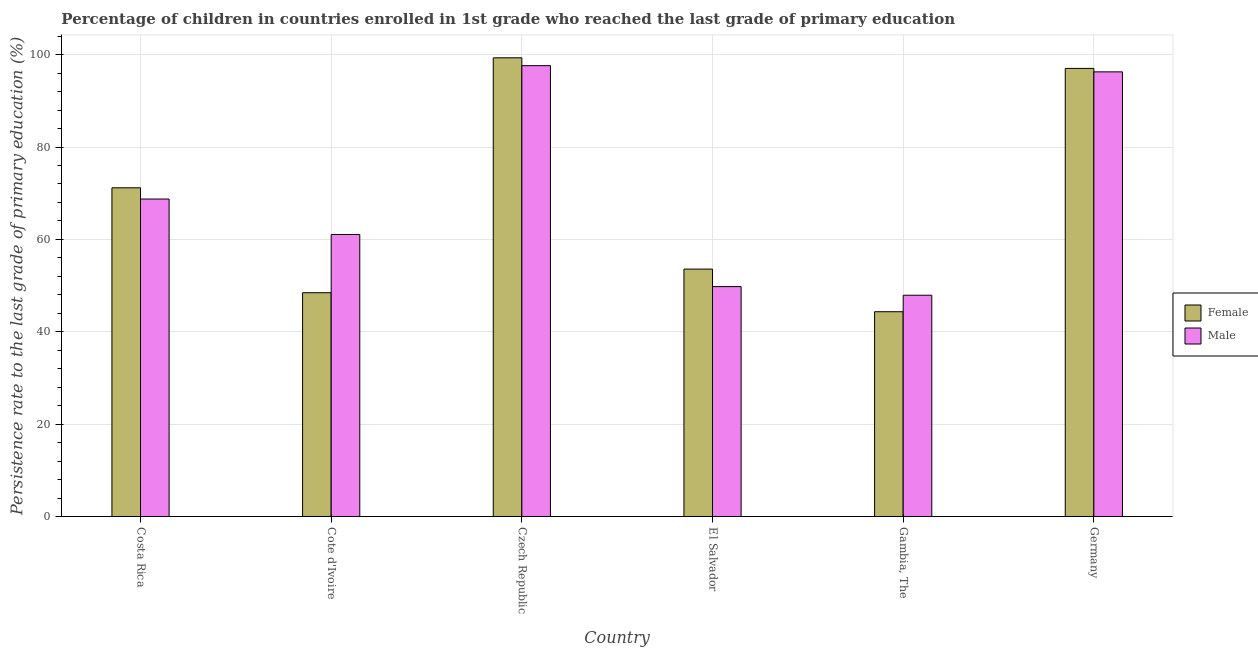How many different coloured bars are there?
Ensure brevity in your answer.  2. How many groups of bars are there?
Your answer should be compact. 6. Are the number of bars on each tick of the X-axis equal?
Your answer should be very brief. Yes. What is the label of the 4th group of bars from the left?
Offer a terse response. El Salvador. In how many cases, is the number of bars for a given country not equal to the number of legend labels?
Keep it short and to the point. 0. What is the persistence rate of female students in Cote d'Ivoire?
Make the answer very short. 48.45. Across all countries, what is the maximum persistence rate of female students?
Keep it short and to the point. 99.33. Across all countries, what is the minimum persistence rate of male students?
Give a very brief answer. 47.91. In which country was the persistence rate of male students maximum?
Your answer should be compact. Czech Republic. In which country was the persistence rate of male students minimum?
Give a very brief answer. Gambia, The. What is the total persistence rate of male students in the graph?
Your answer should be compact. 421.42. What is the difference between the persistence rate of male students in Cote d'Ivoire and that in Gambia, The?
Keep it short and to the point. 13.15. What is the difference between the persistence rate of female students in Gambia, The and the persistence rate of male students in El Salvador?
Your answer should be compact. -5.44. What is the average persistence rate of male students per country?
Provide a short and direct response. 70.24. What is the difference between the persistence rate of female students and persistence rate of male students in Germany?
Provide a succinct answer. 0.75. What is the ratio of the persistence rate of female students in Cote d'Ivoire to that in Czech Republic?
Keep it short and to the point. 0.49. Is the persistence rate of male students in Costa Rica less than that in Germany?
Offer a terse response. Yes. What is the difference between the highest and the second highest persistence rate of male students?
Make the answer very short. 1.34. What is the difference between the highest and the lowest persistence rate of female students?
Your response must be concise. 54.99. In how many countries, is the persistence rate of male students greater than the average persistence rate of male students taken over all countries?
Your response must be concise. 2. Is the sum of the persistence rate of male students in Cote d'Ivoire and Czech Republic greater than the maximum persistence rate of female students across all countries?
Your response must be concise. Yes. Are all the bars in the graph horizontal?
Provide a succinct answer. No. How many countries are there in the graph?
Your answer should be very brief. 6. Are the values on the major ticks of Y-axis written in scientific E-notation?
Offer a terse response. No. How many legend labels are there?
Keep it short and to the point. 2. How are the legend labels stacked?
Your answer should be very brief. Vertical. What is the title of the graph?
Give a very brief answer. Percentage of children in countries enrolled in 1st grade who reached the last grade of primary education. Does "External balance on goods" appear as one of the legend labels in the graph?
Ensure brevity in your answer.  No. What is the label or title of the X-axis?
Offer a very short reply. Country. What is the label or title of the Y-axis?
Make the answer very short. Persistence rate to the last grade of primary education (%). What is the Persistence rate to the last grade of primary education (%) in Female in Costa Rica?
Your response must be concise. 71.18. What is the Persistence rate to the last grade of primary education (%) of Male in Costa Rica?
Ensure brevity in your answer.  68.75. What is the Persistence rate to the last grade of primary education (%) in Female in Cote d'Ivoire?
Provide a short and direct response. 48.45. What is the Persistence rate to the last grade of primary education (%) of Male in Cote d'Ivoire?
Ensure brevity in your answer.  61.06. What is the Persistence rate to the last grade of primary education (%) in Female in Czech Republic?
Provide a short and direct response. 99.33. What is the Persistence rate to the last grade of primary education (%) of Male in Czech Republic?
Provide a short and direct response. 97.63. What is the Persistence rate to the last grade of primary education (%) in Female in El Salvador?
Offer a very short reply. 53.58. What is the Persistence rate to the last grade of primary education (%) in Male in El Salvador?
Your response must be concise. 49.78. What is the Persistence rate to the last grade of primary education (%) in Female in Gambia, The?
Your response must be concise. 44.34. What is the Persistence rate to the last grade of primary education (%) of Male in Gambia, The?
Keep it short and to the point. 47.91. What is the Persistence rate to the last grade of primary education (%) of Female in Germany?
Offer a terse response. 97.03. What is the Persistence rate to the last grade of primary education (%) of Male in Germany?
Offer a very short reply. 96.29. Across all countries, what is the maximum Persistence rate to the last grade of primary education (%) of Female?
Ensure brevity in your answer.  99.33. Across all countries, what is the maximum Persistence rate to the last grade of primary education (%) of Male?
Make the answer very short. 97.63. Across all countries, what is the minimum Persistence rate to the last grade of primary education (%) of Female?
Offer a terse response. 44.34. Across all countries, what is the minimum Persistence rate to the last grade of primary education (%) in Male?
Ensure brevity in your answer.  47.91. What is the total Persistence rate to the last grade of primary education (%) of Female in the graph?
Provide a succinct answer. 413.91. What is the total Persistence rate to the last grade of primary education (%) of Male in the graph?
Provide a short and direct response. 421.42. What is the difference between the Persistence rate to the last grade of primary education (%) of Female in Costa Rica and that in Cote d'Ivoire?
Provide a succinct answer. 22.72. What is the difference between the Persistence rate to the last grade of primary education (%) of Male in Costa Rica and that in Cote d'Ivoire?
Offer a very short reply. 7.68. What is the difference between the Persistence rate to the last grade of primary education (%) of Female in Costa Rica and that in Czech Republic?
Your response must be concise. -28.15. What is the difference between the Persistence rate to the last grade of primary education (%) in Male in Costa Rica and that in Czech Republic?
Make the answer very short. -28.88. What is the difference between the Persistence rate to the last grade of primary education (%) of Female in Costa Rica and that in El Salvador?
Provide a succinct answer. 17.6. What is the difference between the Persistence rate to the last grade of primary education (%) of Male in Costa Rica and that in El Salvador?
Offer a very short reply. 18.96. What is the difference between the Persistence rate to the last grade of primary education (%) in Female in Costa Rica and that in Gambia, The?
Your answer should be very brief. 26.84. What is the difference between the Persistence rate to the last grade of primary education (%) in Male in Costa Rica and that in Gambia, The?
Provide a succinct answer. 20.83. What is the difference between the Persistence rate to the last grade of primary education (%) in Female in Costa Rica and that in Germany?
Offer a terse response. -25.86. What is the difference between the Persistence rate to the last grade of primary education (%) of Male in Costa Rica and that in Germany?
Offer a very short reply. -27.54. What is the difference between the Persistence rate to the last grade of primary education (%) in Female in Cote d'Ivoire and that in Czech Republic?
Ensure brevity in your answer.  -50.87. What is the difference between the Persistence rate to the last grade of primary education (%) of Male in Cote d'Ivoire and that in Czech Republic?
Your answer should be compact. -36.56. What is the difference between the Persistence rate to the last grade of primary education (%) in Female in Cote d'Ivoire and that in El Salvador?
Your answer should be compact. -5.12. What is the difference between the Persistence rate to the last grade of primary education (%) of Male in Cote d'Ivoire and that in El Salvador?
Your answer should be compact. 11.28. What is the difference between the Persistence rate to the last grade of primary education (%) of Female in Cote d'Ivoire and that in Gambia, The?
Make the answer very short. 4.11. What is the difference between the Persistence rate to the last grade of primary education (%) of Male in Cote d'Ivoire and that in Gambia, The?
Your answer should be very brief. 13.15. What is the difference between the Persistence rate to the last grade of primary education (%) in Female in Cote d'Ivoire and that in Germany?
Make the answer very short. -48.58. What is the difference between the Persistence rate to the last grade of primary education (%) in Male in Cote d'Ivoire and that in Germany?
Your response must be concise. -35.22. What is the difference between the Persistence rate to the last grade of primary education (%) of Female in Czech Republic and that in El Salvador?
Your response must be concise. 45.75. What is the difference between the Persistence rate to the last grade of primary education (%) in Male in Czech Republic and that in El Salvador?
Keep it short and to the point. 47.84. What is the difference between the Persistence rate to the last grade of primary education (%) of Female in Czech Republic and that in Gambia, The?
Give a very brief answer. 54.99. What is the difference between the Persistence rate to the last grade of primary education (%) in Male in Czech Republic and that in Gambia, The?
Your response must be concise. 49.72. What is the difference between the Persistence rate to the last grade of primary education (%) of Female in Czech Republic and that in Germany?
Make the answer very short. 2.29. What is the difference between the Persistence rate to the last grade of primary education (%) in Male in Czech Republic and that in Germany?
Give a very brief answer. 1.34. What is the difference between the Persistence rate to the last grade of primary education (%) of Female in El Salvador and that in Gambia, The?
Make the answer very short. 9.23. What is the difference between the Persistence rate to the last grade of primary education (%) in Male in El Salvador and that in Gambia, The?
Offer a terse response. 1.87. What is the difference between the Persistence rate to the last grade of primary education (%) of Female in El Salvador and that in Germany?
Your answer should be very brief. -43.46. What is the difference between the Persistence rate to the last grade of primary education (%) in Male in El Salvador and that in Germany?
Your answer should be very brief. -46.5. What is the difference between the Persistence rate to the last grade of primary education (%) in Female in Gambia, The and that in Germany?
Your answer should be very brief. -52.69. What is the difference between the Persistence rate to the last grade of primary education (%) of Male in Gambia, The and that in Germany?
Ensure brevity in your answer.  -48.37. What is the difference between the Persistence rate to the last grade of primary education (%) of Female in Costa Rica and the Persistence rate to the last grade of primary education (%) of Male in Cote d'Ivoire?
Provide a succinct answer. 10.11. What is the difference between the Persistence rate to the last grade of primary education (%) of Female in Costa Rica and the Persistence rate to the last grade of primary education (%) of Male in Czech Republic?
Provide a short and direct response. -26.45. What is the difference between the Persistence rate to the last grade of primary education (%) of Female in Costa Rica and the Persistence rate to the last grade of primary education (%) of Male in El Salvador?
Your answer should be compact. 21.39. What is the difference between the Persistence rate to the last grade of primary education (%) in Female in Costa Rica and the Persistence rate to the last grade of primary education (%) in Male in Gambia, The?
Your response must be concise. 23.26. What is the difference between the Persistence rate to the last grade of primary education (%) of Female in Costa Rica and the Persistence rate to the last grade of primary education (%) of Male in Germany?
Provide a short and direct response. -25.11. What is the difference between the Persistence rate to the last grade of primary education (%) in Female in Cote d'Ivoire and the Persistence rate to the last grade of primary education (%) in Male in Czech Republic?
Offer a very short reply. -49.17. What is the difference between the Persistence rate to the last grade of primary education (%) of Female in Cote d'Ivoire and the Persistence rate to the last grade of primary education (%) of Male in El Salvador?
Your answer should be compact. -1.33. What is the difference between the Persistence rate to the last grade of primary education (%) of Female in Cote d'Ivoire and the Persistence rate to the last grade of primary education (%) of Male in Gambia, The?
Your answer should be compact. 0.54. What is the difference between the Persistence rate to the last grade of primary education (%) of Female in Cote d'Ivoire and the Persistence rate to the last grade of primary education (%) of Male in Germany?
Provide a short and direct response. -47.83. What is the difference between the Persistence rate to the last grade of primary education (%) of Female in Czech Republic and the Persistence rate to the last grade of primary education (%) of Male in El Salvador?
Provide a short and direct response. 49.54. What is the difference between the Persistence rate to the last grade of primary education (%) in Female in Czech Republic and the Persistence rate to the last grade of primary education (%) in Male in Gambia, The?
Keep it short and to the point. 51.41. What is the difference between the Persistence rate to the last grade of primary education (%) in Female in Czech Republic and the Persistence rate to the last grade of primary education (%) in Male in Germany?
Make the answer very short. 3.04. What is the difference between the Persistence rate to the last grade of primary education (%) of Female in El Salvador and the Persistence rate to the last grade of primary education (%) of Male in Gambia, The?
Your answer should be compact. 5.66. What is the difference between the Persistence rate to the last grade of primary education (%) of Female in El Salvador and the Persistence rate to the last grade of primary education (%) of Male in Germany?
Your answer should be compact. -42.71. What is the difference between the Persistence rate to the last grade of primary education (%) in Female in Gambia, The and the Persistence rate to the last grade of primary education (%) in Male in Germany?
Provide a succinct answer. -51.94. What is the average Persistence rate to the last grade of primary education (%) in Female per country?
Provide a succinct answer. 68.98. What is the average Persistence rate to the last grade of primary education (%) of Male per country?
Keep it short and to the point. 70.24. What is the difference between the Persistence rate to the last grade of primary education (%) of Female and Persistence rate to the last grade of primary education (%) of Male in Costa Rica?
Offer a terse response. 2.43. What is the difference between the Persistence rate to the last grade of primary education (%) in Female and Persistence rate to the last grade of primary education (%) in Male in Cote d'Ivoire?
Offer a very short reply. -12.61. What is the difference between the Persistence rate to the last grade of primary education (%) in Female and Persistence rate to the last grade of primary education (%) in Male in Czech Republic?
Give a very brief answer. 1.7. What is the difference between the Persistence rate to the last grade of primary education (%) of Female and Persistence rate to the last grade of primary education (%) of Male in El Salvador?
Your response must be concise. 3.79. What is the difference between the Persistence rate to the last grade of primary education (%) of Female and Persistence rate to the last grade of primary education (%) of Male in Gambia, The?
Your answer should be compact. -3.57. What is the difference between the Persistence rate to the last grade of primary education (%) in Female and Persistence rate to the last grade of primary education (%) in Male in Germany?
Give a very brief answer. 0.75. What is the ratio of the Persistence rate to the last grade of primary education (%) of Female in Costa Rica to that in Cote d'Ivoire?
Offer a terse response. 1.47. What is the ratio of the Persistence rate to the last grade of primary education (%) in Male in Costa Rica to that in Cote d'Ivoire?
Provide a short and direct response. 1.13. What is the ratio of the Persistence rate to the last grade of primary education (%) in Female in Costa Rica to that in Czech Republic?
Give a very brief answer. 0.72. What is the ratio of the Persistence rate to the last grade of primary education (%) of Male in Costa Rica to that in Czech Republic?
Provide a succinct answer. 0.7. What is the ratio of the Persistence rate to the last grade of primary education (%) in Female in Costa Rica to that in El Salvador?
Make the answer very short. 1.33. What is the ratio of the Persistence rate to the last grade of primary education (%) of Male in Costa Rica to that in El Salvador?
Your answer should be very brief. 1.38. What is the ratio of the Persistence rate to the last grade of primary education (%) in Female in Costa Rica to that in Gambia, The?
Make the answer very short. 1.61. What is the ratio of the Persistence rate to the last grade of primary education (%) of Male in Costa Rica to that in Gambia, The?
Ensure brevity in your answer.  1.43. What is the ratio of the Persistence rate to the last grade of primary education (%) of Female in Costa Rica to that in Germany?
Keep it short and to the point. 0.73. What is the ratio of the Persistence rate to the last grade of primary education (%) of Male in Costa Rica to that in Germany?
Provide a short and direct response. 0.71. What is the ratio of the Persistence rate to the last grade of primary education (%) of Female in Cote d'Ivoire to that in Czech Republic?
Your response must be concise. 0.49. What is the ratio of the Persistence rate to the last grade of primary education (%) of Male in Cote d'Ivoire to that in Czech Republic?
Make the answer very short. 0.63. What is the ratio of the Persistence rate to the last grade of primary education (%) in Female in Cote d'Ivoire to that in El Salvador?
Provide a succinct answer. 0.9. What is the ratio of the Persistence rate to the last grade of primary education (%) in Male in Cote d'Ivoire to that in El Salvador?
Give a very brief answer. 1.23. What is the ratio of the Persistence rate to the last grade of primary education (%) of Female in Cote d'Ivoire to that in Gambia, The?
Your response must be concise. 1.09. What is the ratio of the Persistence rate to the last grade of primary education (%) of Male in Cote d'Ivoire to that in Gambia, The?
Make the answer very short. 1.27. What is the ratio of the Persistence rate to the last grade of primary education (%) of Female in Cote d'Ivoire to that in Germany?
Ensure brevity in your answer.  0.5. What is the ratio of the Persistence rate to the last grade of primary education (%) of Male in Cote d'Ivoire to that in Germany?
Ensure brevity in your answer.  0.63. What is the ratio of the Persistence rate to the last grade of primary education (%) in Female in Czech Republic to that in El Salvador?
Your response must be concise. 1.85. What is the ratio of the Persistence rate to the last grade of primary education (%) in Male in Czech Republic to that in El Salvador?
Your answer should be compact. 1.96. What is the ratio of the Persistence rate to the last grade of primary education (%) of Female in Czech Republic to that in Gambia, The?
Ensure brevity in your answer.  2.24. What is the ratio of the Persistence rate to the last grade of primary education (%) in Male in Czech Republic to that in Gambia, The?
Make the answer very short. 2.04. What is the ratio of the Persistence rate to the last grade of primary education (%) of Female in Czech Republic to that in Germany?
Your answer should be compact. 1.02. What is the ratio of the Persistence rate to the last grade of primary education (%) of Male in Czech Republic to that in Germany?
Make the answer very short. 1.01. What is the ratio of the Persistence rate to the last grade of primary education (%) in Female in El Salvador to that in Gambia, The?
Keep it short and to the point. 1.21. What is the ratio of the Persistence rate to the last grade of primary education (%) of Male in El Salvador to that in Gambia, The?
Offer a terse response. 1.04. What is the ratio of the Persistence rate to the last grade of primary education (%) in Female in El Salvador to that in Germany?
Offer a terse response. 0.55. What is the ratio of the Persistence rate to the last grade of primary education (%) in Male in El Salvador to that in Germany?
Provide a short and direct response. 0.52. What is the ratio of the Persistence rate to the last grade of primary education (%) in Female in Gambia, The to that in Germany?
Give a very brief answer. 0.46. What is the ratio of the Persistence rate to the last grade of primary education (%) in Male in Gambia, The to that in Germany?
Ensure brevity in your answer.  0.5. What is the difference between the highest and the second highest Persistence rate to the last grade of primary education (%) of Female?
Your response must be concise. 2.29. What is the difference between the highest and the second highest Persistence rate to the last grade of primary education (%) of Male?
Provide a short and direct response. 1.34. What is the difference between the highest and the lowest Persistence rate to the last grade of primary education (%) in Female?
Make the answer very short. 54.99. What is the difference between the highest and the lowest Persistence rate to the last grade of primary education (%) in Male?
Offer a terse response. 49.72. 